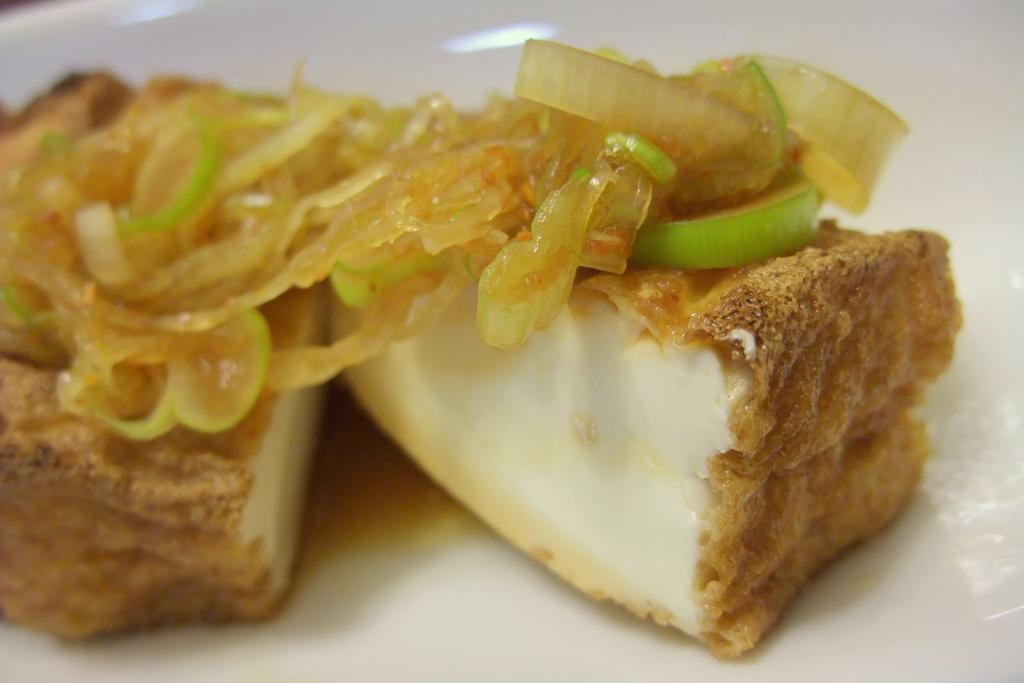What is present on the plate in the image? There is a plate of food item in the image. What type of force is being applied to the food item on the plate? There is no indication of any force being applied to the food item on the plate in the image. 